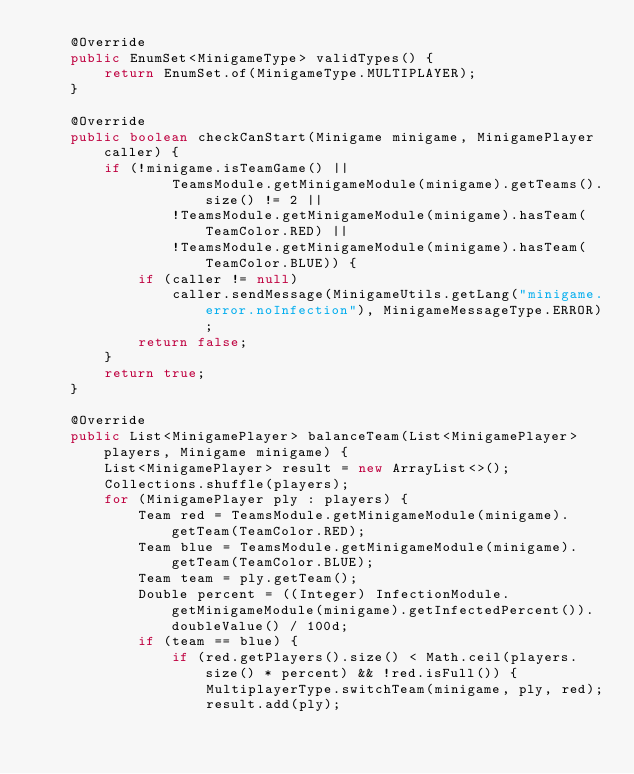<code> <loc_0><loc_0><loc_500><loc_500><_Java_>    @Override
    public EnumSet<MinigameType> validTypes() {
        return EnumSet.of(MinigameType.MULTIPLAYER);
    }

    @Override
    public boolean checkCanStart(Minigame minigame, MinigamePlayer caller) {
        if (!minigame.isTeamGame() ||
                TeamsModule.getMinigameModule(minigame).getTeams().size() != 2 ||
                !TeamsModule.getMinigameModule(minigame).hasTeam(TeamColor.RED) ||
                !TeamsModule.getMinigameModule(minigame).hasTeam(TeamColor.BLUE)) {
            if (caller != null)
                caller.sendMessage(MinigameUtils.getLang("minigame.error.noInfection"), MinigameMessageType.ERROR);
            return false;
        }
        return true;
    }

    @Override
    public List<MinigamePlayer> balanceTeam(List<MinigamePlayer> players, Minigame minigame) {
        List<MinigamePlayer> result = new ArrayList<>();
        Collections.shuffle(players);
        for (MinigamePlayer ply : players) {
            Team red = TeamsModule.getMinigameModule(minigame).getTeam(TeamColor.RED);
            Team blue = TeamsModule.getMinigameModule(minigame).getTeam(TeamColor.BLUE);
            Team team = ply.getTeam();
            Double percent = ((Integer) InfectionModule.getMinigameModule(minigame).getInfectedPercent()).doubleValue() / 100d;
            if (team == blue) {
                if (red.getPlayers().size() < Math.ceil(players.size() * percent) && !red.isFull()) {
                    MultiplayerType.switchTeam(minigame, ply, red);
                    result.add(ply);</code> 